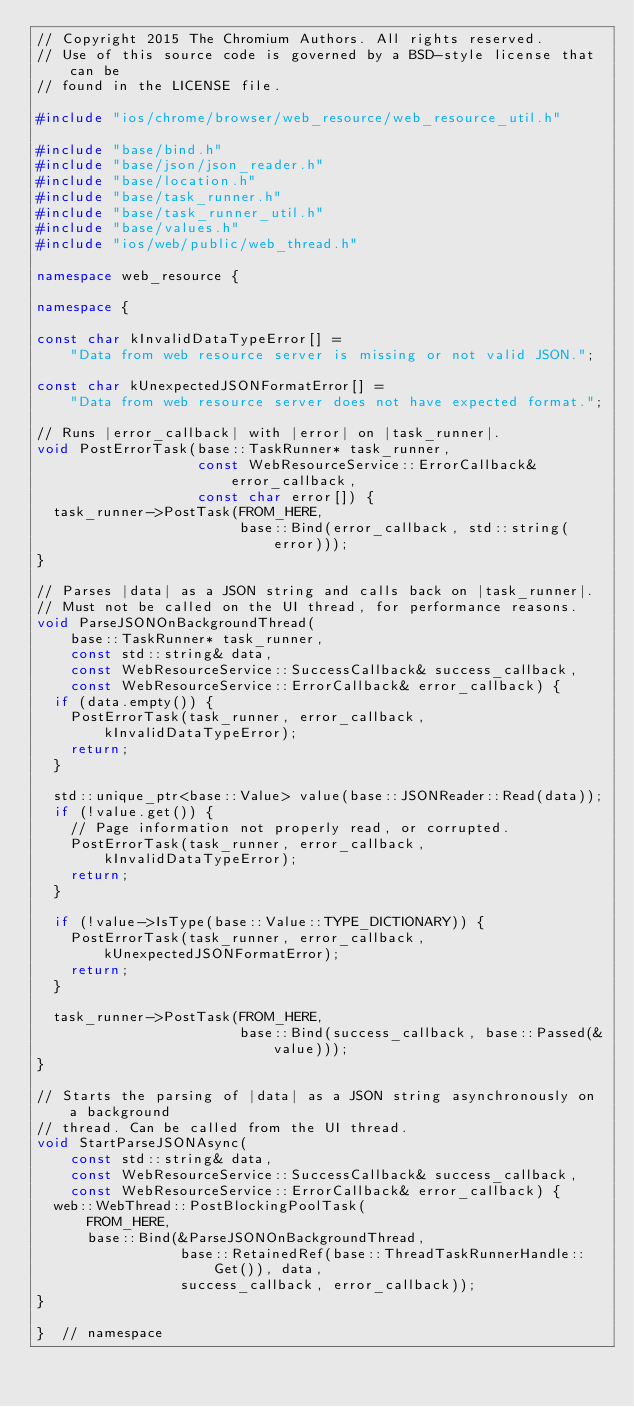Convert code to text. <code><loc_0><loc_0><loc_500><loc_500><_C++_>// Copyright 2015 The Chromium Authors. All rights reserved.
// Use of this source code is governed by a BSD-style license that can be
// found in the LICENSE file.

#include "ios/chrome/browser/web_resource/web_resource_util.h"

#include "base/bind.h"
#include "base/json/json_reader.h"
#include "base/location.h"
#include "base/task_runner.h"
#include "base/task_runner_util.h"
#include "base/values.h"
#include "ios/web/public/web_thread.h"

namespace web_resource {

namespace {

const char kInvalidDataTypeError[] =
    "Data from web resource server is missing or not valid JSON.";

const char kUnexpectedJSONFormatError[] =
    "Data from web resource server does not have expected format.";

// Runs |error_callback| with |error| on |task_runner|.
void PostErrorTask(base::TaskRunner* task_runner,
                   const WebResourceService::ErrorCallback& error_callback,
                   const char error[]) {
  task_runner->PostTask(FROM_HERE,
                        base::Bind(error_callback, std::string(error)));
}

// Parses |data| as a JSON string and calls back on |task_runner|.
// Must not be called on the UI thread, for performance reasons.
void ParseJSONOnBackgroundThread(
    base::TaskRunner* task_runner,
    const std::string& data,
    const WebResourceService::SuccessCallback& success_callback,
    const WebResourceService::ErrorCallback& error_callback) {
  if (data.empty()) {
    PostErrorTask(task_runner, error_callback, kInvalidDataTypeError);
    return;
  }

  std::unique_ptr<base::Value> value(base::JSONReader::Read(data));
  if (!value.get()) {
    // Page information not properly read, or corrupted.
    PostErrorTask(task_runner, error_callback, kInvalidDataTypeError);
    return;
  }

  if (!value->IsType(base::Value::TYPE_DICTIONARY)) {
    PostErrorTask(task_runner, error_callback, kUnexpectedJSONFormatError);
    return;
  }

  task_runner->PostTask(FROM_HERE,
                        base::Bind(success_callback, base::Passed(&value)));
}

// Starts the parsing of |data| as a JSON string asynchronously on a background
// thread. Can be called from the UI thread.
void StartParseJSONAsync(
    const std::string& data,
    const WebResourceService::SuccessCallback& success_callback,
    const WebResourceService::ErrorCallback& error_callback) {
  web::WebThread::PostBlockingPoolTask(
      FROM_HERE,
      base::Bind(&ParseJSONOnBackgroundThread,
                 base::RetainedRef(base::ThreadTaskRunnerHandle::Get()), data,
                 success_callback, error_callback));
}

}  // namespace
</code> 